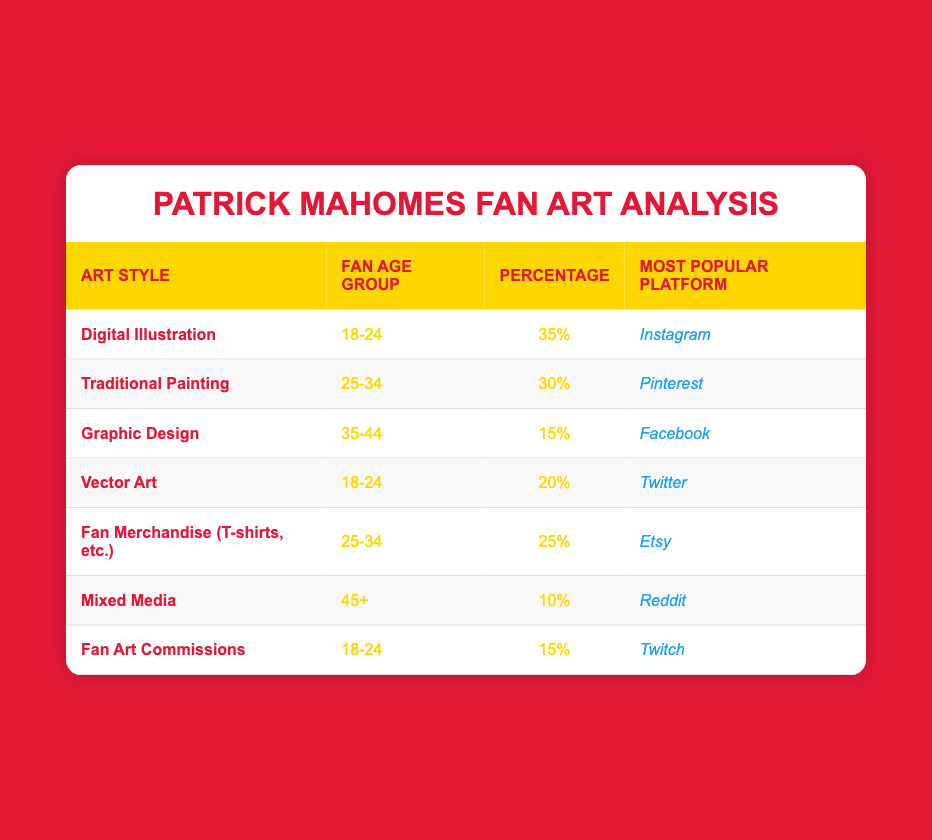What percentage of 18-24 age group fans prefer Digital Illustration? According to the table, the percentage for Digital Illustration in the 18-24 age group is listed directly as 35%.
Answer: 35% Which fan age group has the highest percentage for Traditional Painting? The fan age group for Traditional Painting is 25-34, with a percentage of 30%, which is the highest for that specific art style.
Answer: 25-34 How many more fans in the 18-24 age group prefer Digital Illustration compared to Fan Art Commissions? From the table, Digital Illustration has 35% and Fan Art Commissions has 15% in the 18-24 age group. The difference is 35% - 15% = 20%.
Answer: 20% Is Mixed Media more popular among fans aged 45+ than Graphic Design among fans aged 35-44? Mixed Media has 10% popularity among the 45+ age group, while Graphic Design has 15% among the 35-44 age group. Since 10% is less than 15%, this statement is false.
Answer: No What is the total percentage of fans aged 25-34 that prefer either Traditional Painting or Fan Merchandise? The percentage for Traditional Painting is 30% and for Fan Merchandise it is 25%. To find the total, we add them: 30% + 25% = 55%.
Answer: 55% Which platform is most popular for fans aged 25-34 who enjoy fan merchandise? The table indicates that the most popular platform for Fan Merchandise among fans aged 25-34 is Etsy.
Answer: Etsy What is the average percentage of the 18-24 age group when considering Digital Illustration, Vector Art, and Fan Art Commissions? For the 18-24 age group, the percentages are 35% (Digital Illustration), 20% (Vector Art), and 15% (Fan Art Commissions). To find the average, we sum these percentages (35 + 20 + 15) = 70%, then divide by 3, resulting in 70% / 3 = 23.33%.
Answer: 23.33% For what percentage is the interest in Graphic Design compared to the total interest of the three youngest age groups (18-24, 25-34, and 35-44)? The percentages for these age groups are 35% (18-24), 30% (25-34), and 15% (35-44), totaling 80%. Graphic Design has a 15% interest. To find the percentage of Graphic Design compared to the total, we do (15 / 80) * 100 = 18.75%.
Answer: 18.75% 